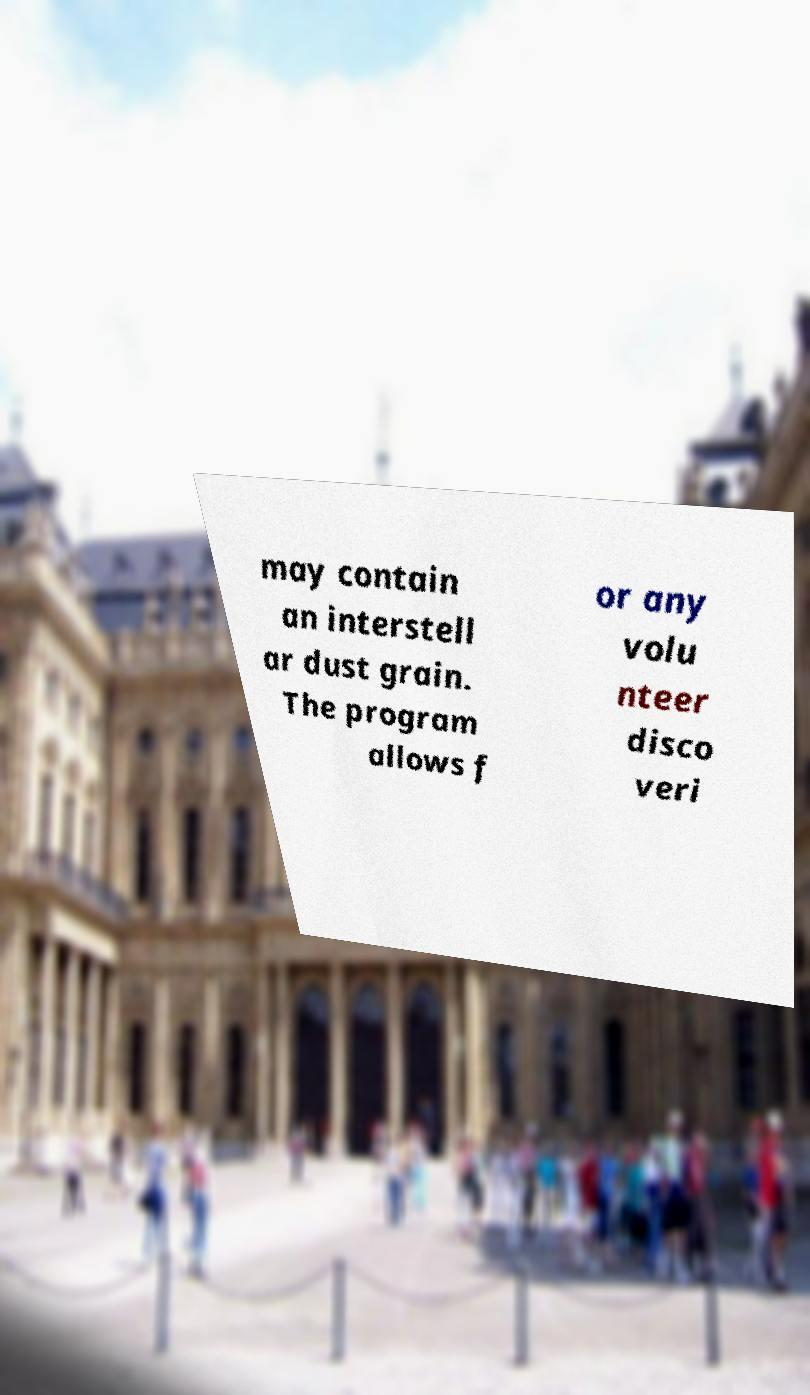Could you assist in decoding the text presented in this image and type it out clearly? may contain an interstell ar dust grain. The program allows f or any volu nteer disco veri 